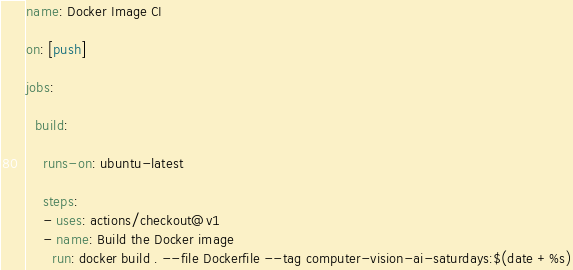<code> <loc_0><loc_0><loc_500><loc_500><_YAML_>name: Docker Image CI

on: [push]

jobs:

  build:

    runs-on: ubuntu-latest

    steps:
    - uses: actions/checkout@v1
    - name: Build the Docker image
      run: docker build . --file Dockerfile --tag computer-vision-ai-saturdays:$(date +%s)
</code> 